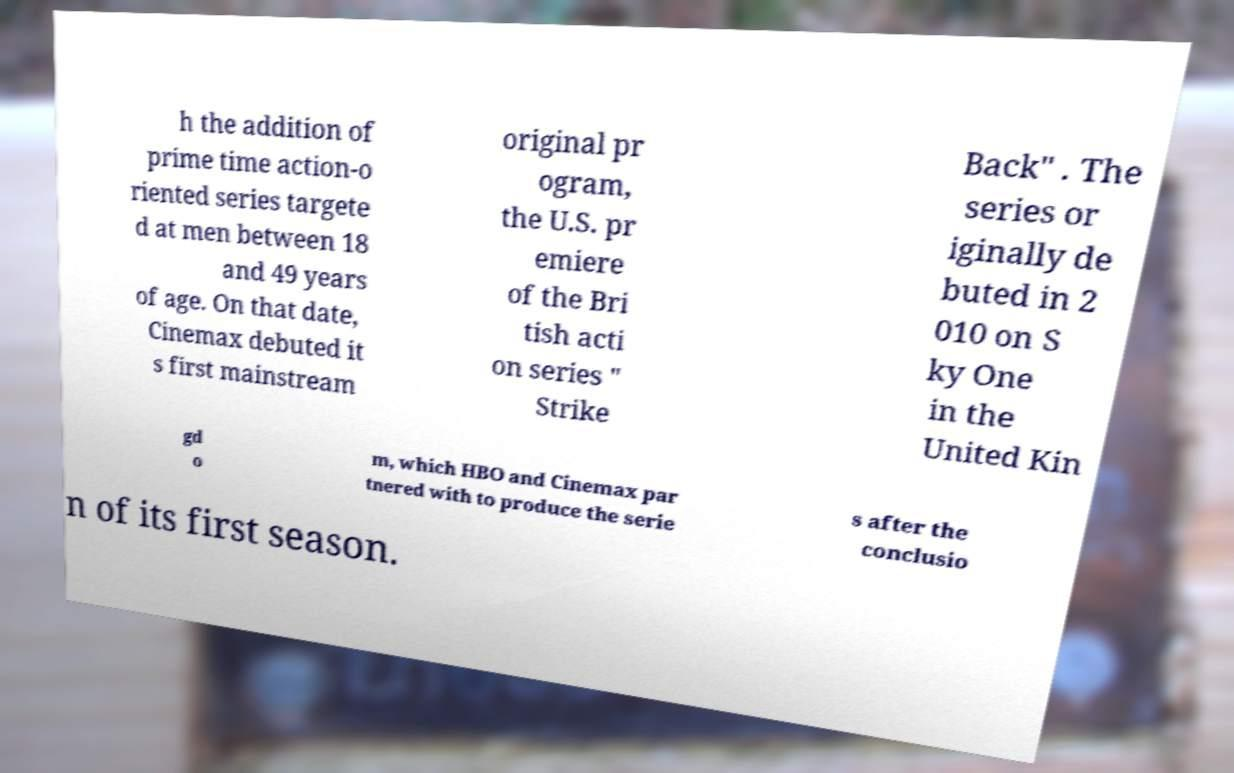Please read and relay the text visible in this image. What does it say? h the addition of prime time action-o riented series targete d at men between 18 and 49 years of age. On that date, Cinemax debuted it s first mainstream original pr ogram, the U.S. pr emiere of the Bri tish acti on series " Strike Back" . The series or iginally de buted in 2 010 on S ky One in the United Kin gd o m, which HBO and Cinemax par tnered with to produce the serie s after the conclusio n of its first season. 